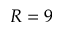Convert formula to latex. <formula><loc_0><loc_0><loc_500><loc_500>R = 9</formula> 